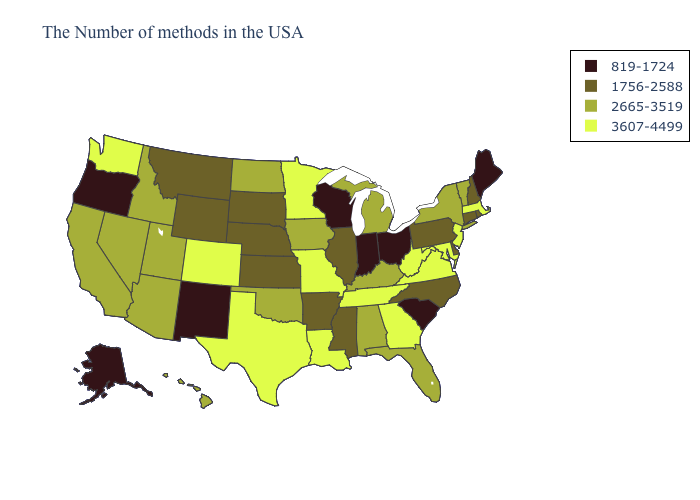What is the value of Arkansas?
Keep it brief. 1756-2588. What is the lowest value in the USA?
Be succinct. 819-1724. What is the value of Minnesota?
Write a very short answer. 3607-4499. What is the highest value in states that border South Carolina?
Write a very short answer. 3607-4499. Name the states that have a value in the range 819-1724?
Be succinct. Maine, South Carolina, Ohio, Indiana, Wisconsin, New Mexico, Oregon, Alaska. Does Arkansas have the highest value in the USA?
Give a very brief answer. No. What is the value of Wyoming?
Short answer required. 1756-2588. Among the states that border New Hampshire , does Maine have the highest value?
Write a very short answer. No. Name the states that have a value in the range 819-1724?
Quick response, please. Maine, South Carolina, Ohio, Indiana, Wisconsin, New Mexico, Oregon, Alaska. What is the lowest value in the West?
Keep it brief. 819-1724. What is the value of North Carolina?
Quick response, please. 1756-2588. What is the value of Alaska?
Give a very brief answer. 819-1724. Does Alabama have a lower value than Missouri?
Write a very short answer. Yes. What is the lowest value in the USA?
Short answer required. 819-1724. 